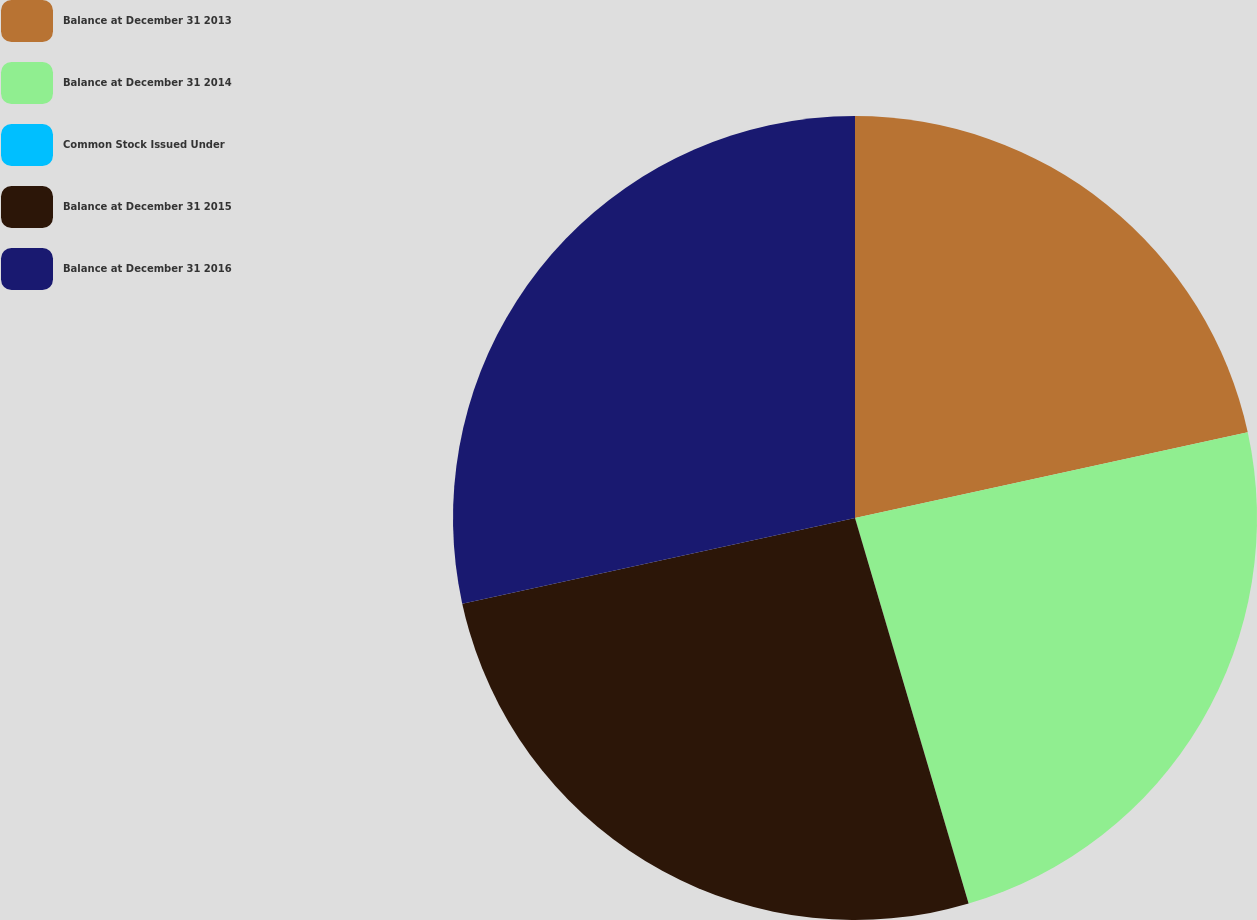<chart> <loc_0><loc_0><loc_500><loc_500><pie_chart><fcel>Balance at December 31 2013<fcel>Balance at December 31 2014<fcel>Common Stock Issued Under<fcel>Balance at December 31 2015<fcel>Balance at December 31 2016<nl><fcel>21.58%<fcel>23.86%<fcel>0.0%<fcel>26.14%<fcel>28.42%<nl></chart> 